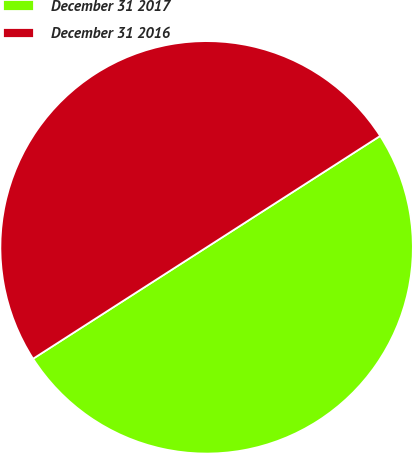<chart> <loc_0><loc_0><loc_500><loc_500><pie_chart><fcel>December 31 2017<fcel>December 31 2016<nl><fcel>50.0%<fcel>50.0%<nl></chart> 